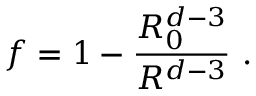Convert formula to latex. <formula><loc_0><loc_0><loc_500><loc_500>f = 1 - \frac { R _ { 0 } ^ { d - 3 } } { R ^ { d - 3 } } \ .</formula> 